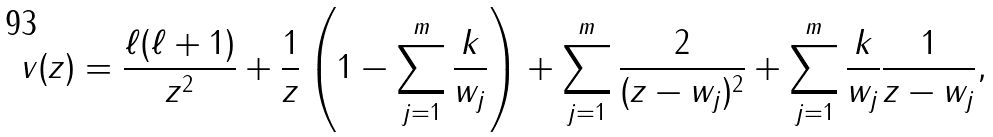<formula> <loc_0><loc_0><loc_500><loc_500>v ( z ) = \frac { \ell ( \ell + 1 ) } { z ^ { 2 } } + \frac { 1 } { z } \left ( 1 - \sum _ { j = 1 } ^ { m } \frac { k } { w _ { j } } \right ) + \sum _ { j = 1 } ^ { m } \frac { 2 } { ( z - w _ { j } ) ^ { 2 } } + \sum _ { j = 1 } ^ { m } \frac { k } { w _ { j } } \frac { 1 } { z - w _ { j } } ,</formula> 